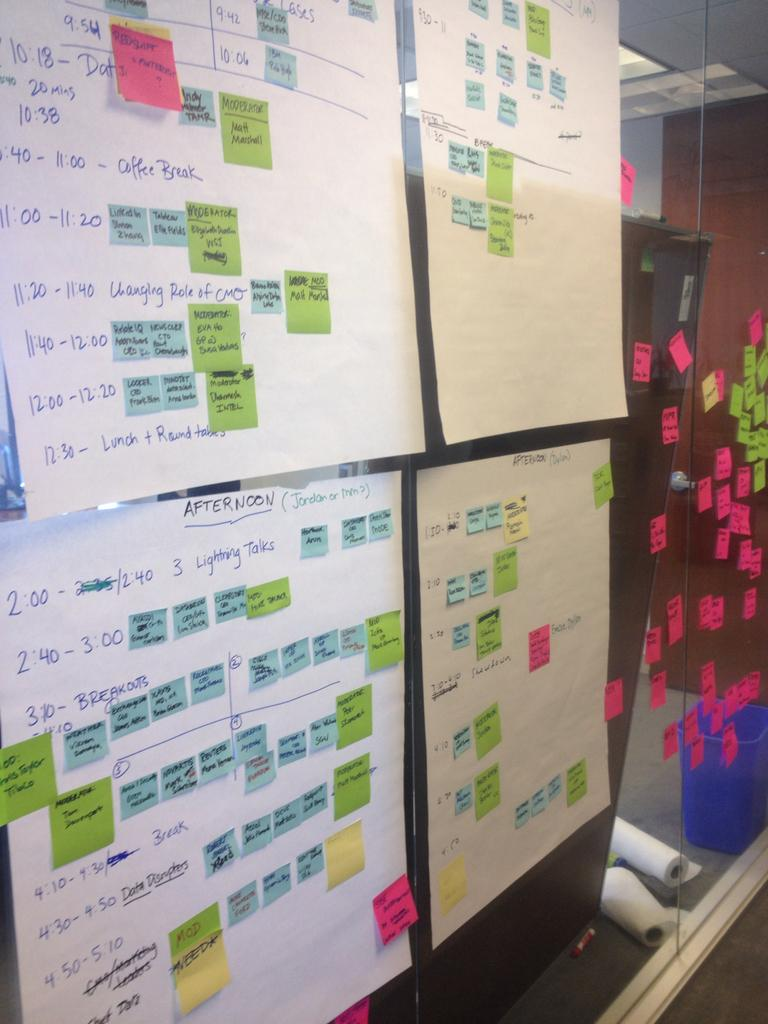Provide a one-sentence caption for the provided image. Several schedules on a wall with the 3:10 slot named Breakouts. 